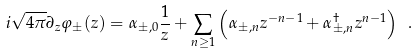Convert formula to latex. <formula><loc_0><loc_0><loc_500><loc_500>i \sqrt { 4 \pi } \partial _ { z } \varphi _ { \pm } ( z ) = \alpha _ { \pm , 0 } \frac { 1 } { z } + \sum _ { n \geq 1 } \left ( \alpha _ { \pm , n } z ^ { - n - 1 } + \alpha _ { \pm , n } ^ { \dagger } z ^ { n - 1 } \right ) \ .</formula> 